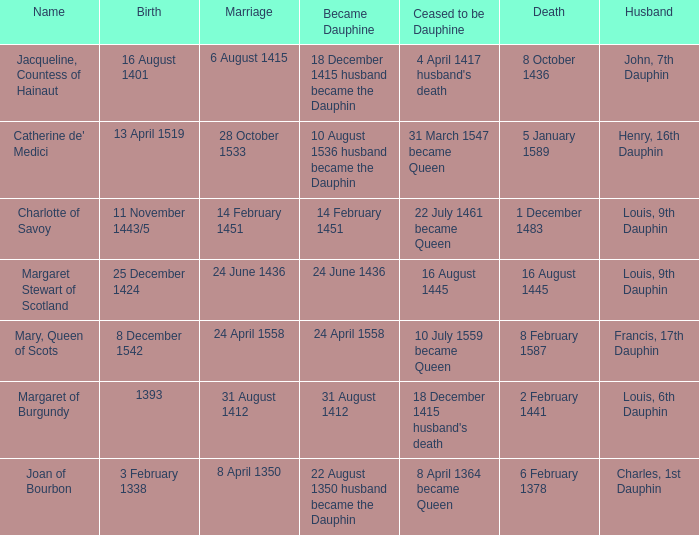Who is the husband when ceased to be dauphine is 22 july 1461 became queen? Louis, 9th Dauphin. 